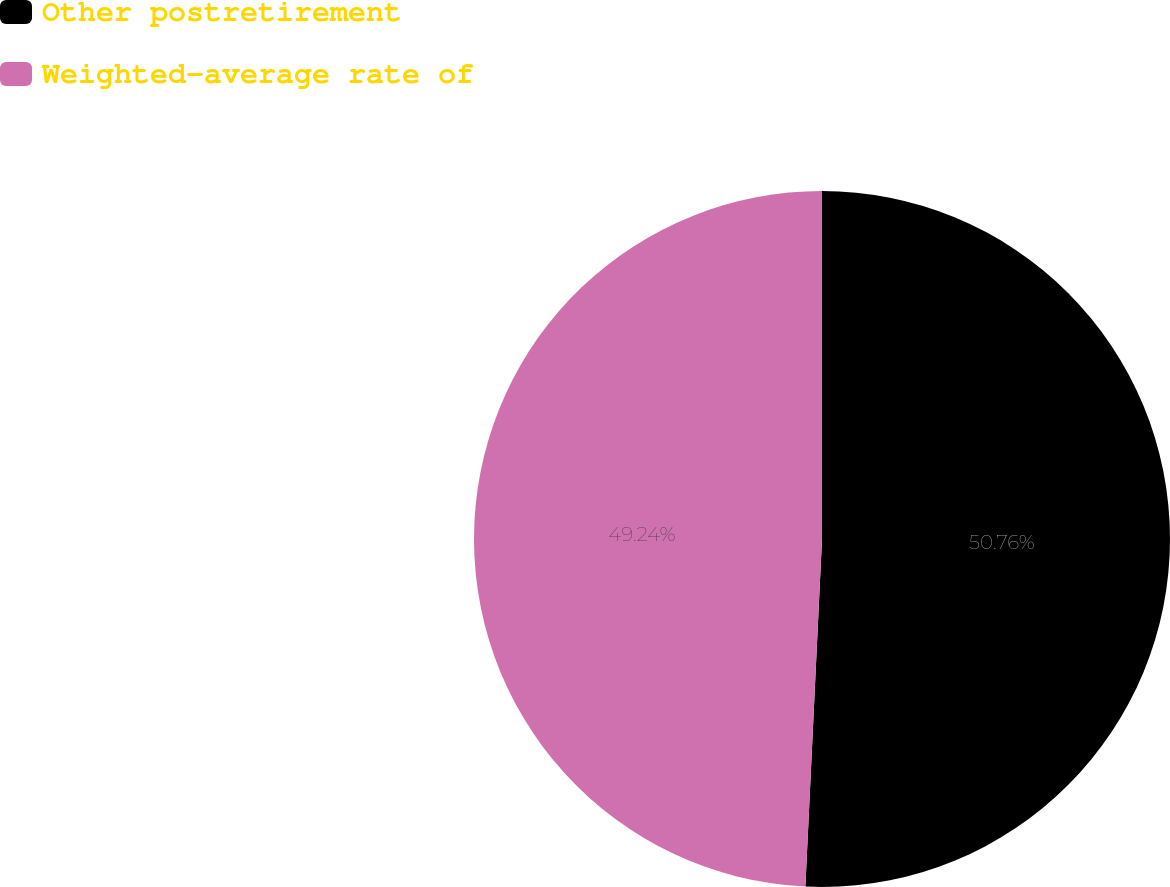<chart> <loc_0><loc_0><loc_500><loc_500><pie_chart><fcel>Other postretirement<fcel>Weighted-average rate of<nl><fcel>50.76%<fcel>49.24%<nl></chart> 